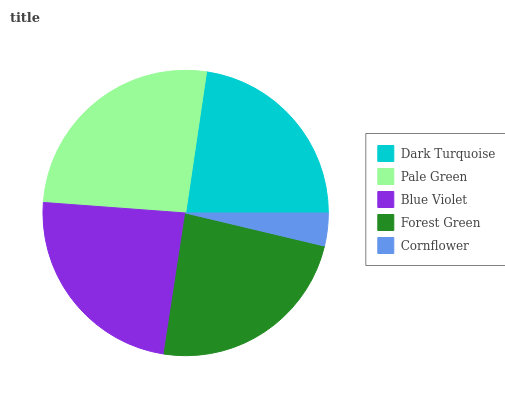Is Cornflower the minimum?
Answer yes or no. Yes. Is Pale Green the maximum?
Answer yes or no. Yes. Is Blue Violet the minimum?
Answer yes or no. No. Is Blue Violet the maximum?
Answer yes or no. No. Is Pale Green greater than Blue Violet?
Answer yes or no. Yes. Is Blue Violet less than Pale Green?
Answer yes or no. Yes. Is Blue Violet greater than Pale Green?
Answer yes or no. No. Is Pale Green less than Blue Violet?
Answer yes or no. No. Is Forest Green the high median?
Answer yes or no. Yes. Is Forest Green the low median?
Answer yes or no. Yes. Is Cornflower the high median?
Answer yes or no. No. Is Pale Green the low median?
Answer yes or no. No. 